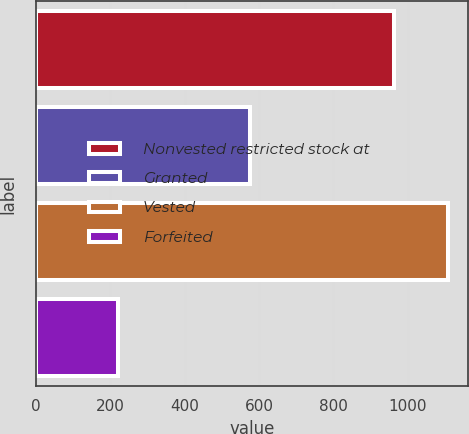Convert chart to OTSL. <chart><loc_0><loc_0><loc_500><loc_500><bar_chart><fcel>Nonvested restricted stock at<fcel>Granted<fcel>Vested<fcel>Forfeited<nl><fcel>964<fcel>576<fcel>1107.3<fcel>220<nl></chart> 